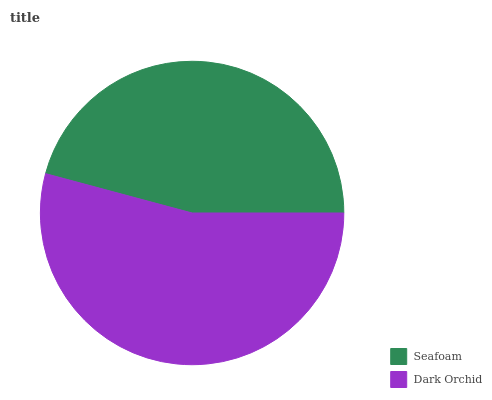Is Seafoam the minimum?
Answer yes or no. Yes. Is Dark Orchid the maximum?
Answer yes or no. Yes. Is Dark Orchid the minimum?
Answer yes or no. No. Is Dark Orchid greater than Seafoam?
Answer yes or no. Yes. Is Seafoam less than Dark Orchid?
Answer yes or no. Yes. Is Seafoam greater than Dark Orchid?
Answer yes or no. No. Is Dark Orchid less than Seafoam?
Answer yes or no. No. Is Dark Orchid the high median?
Answer yes or no. Yes. Is Seafoam the low median?
Answer yes or no. Yes. Is Seafoam the high median?
Answer yes or no. No. Is Dark Orchid the low median?
Answer yes or no. No. 